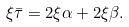<formula> <loc_0><loc_0><loc_500><loc_500>\xi \bar { \tau } = 2 \xi \alpha + 2 \xi \beta .</formula> 